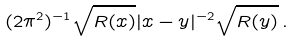Convert formula to latex. <formula><loc_0><loc_0><loc_500><loc_500>( 2 \pi ^ { 2 } ) ^ { - 1 } \sqrt { R ( x ) } | x - y | ^ { - 2 } \sqrt { R ( y ) } \, .</formula> 